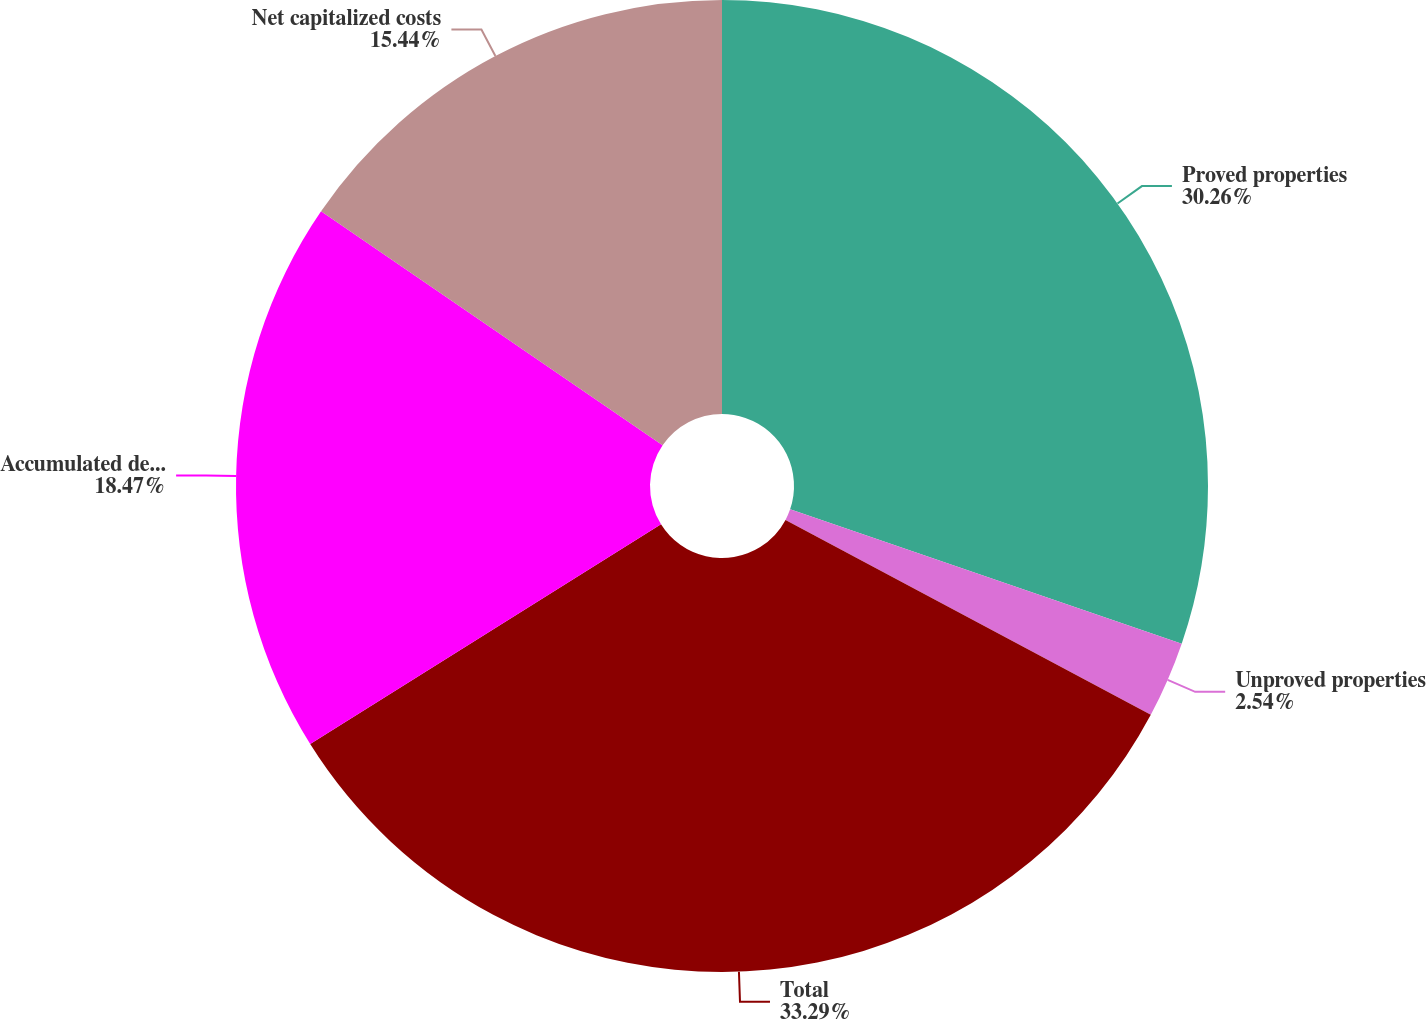<chart> <loc_0><loc_0><loc_500><loc_500><pie_chart><fcel>Proved properties<fcel>Unproved properties<fcel>Total<fcel>Accumulated depreciation<fcel>Net capitalized costs<nl><fcel>30.26%<fcel>2.54%<fcel>33.29%<fcel>18.47%<fcel>15.44%<nl></chart> 